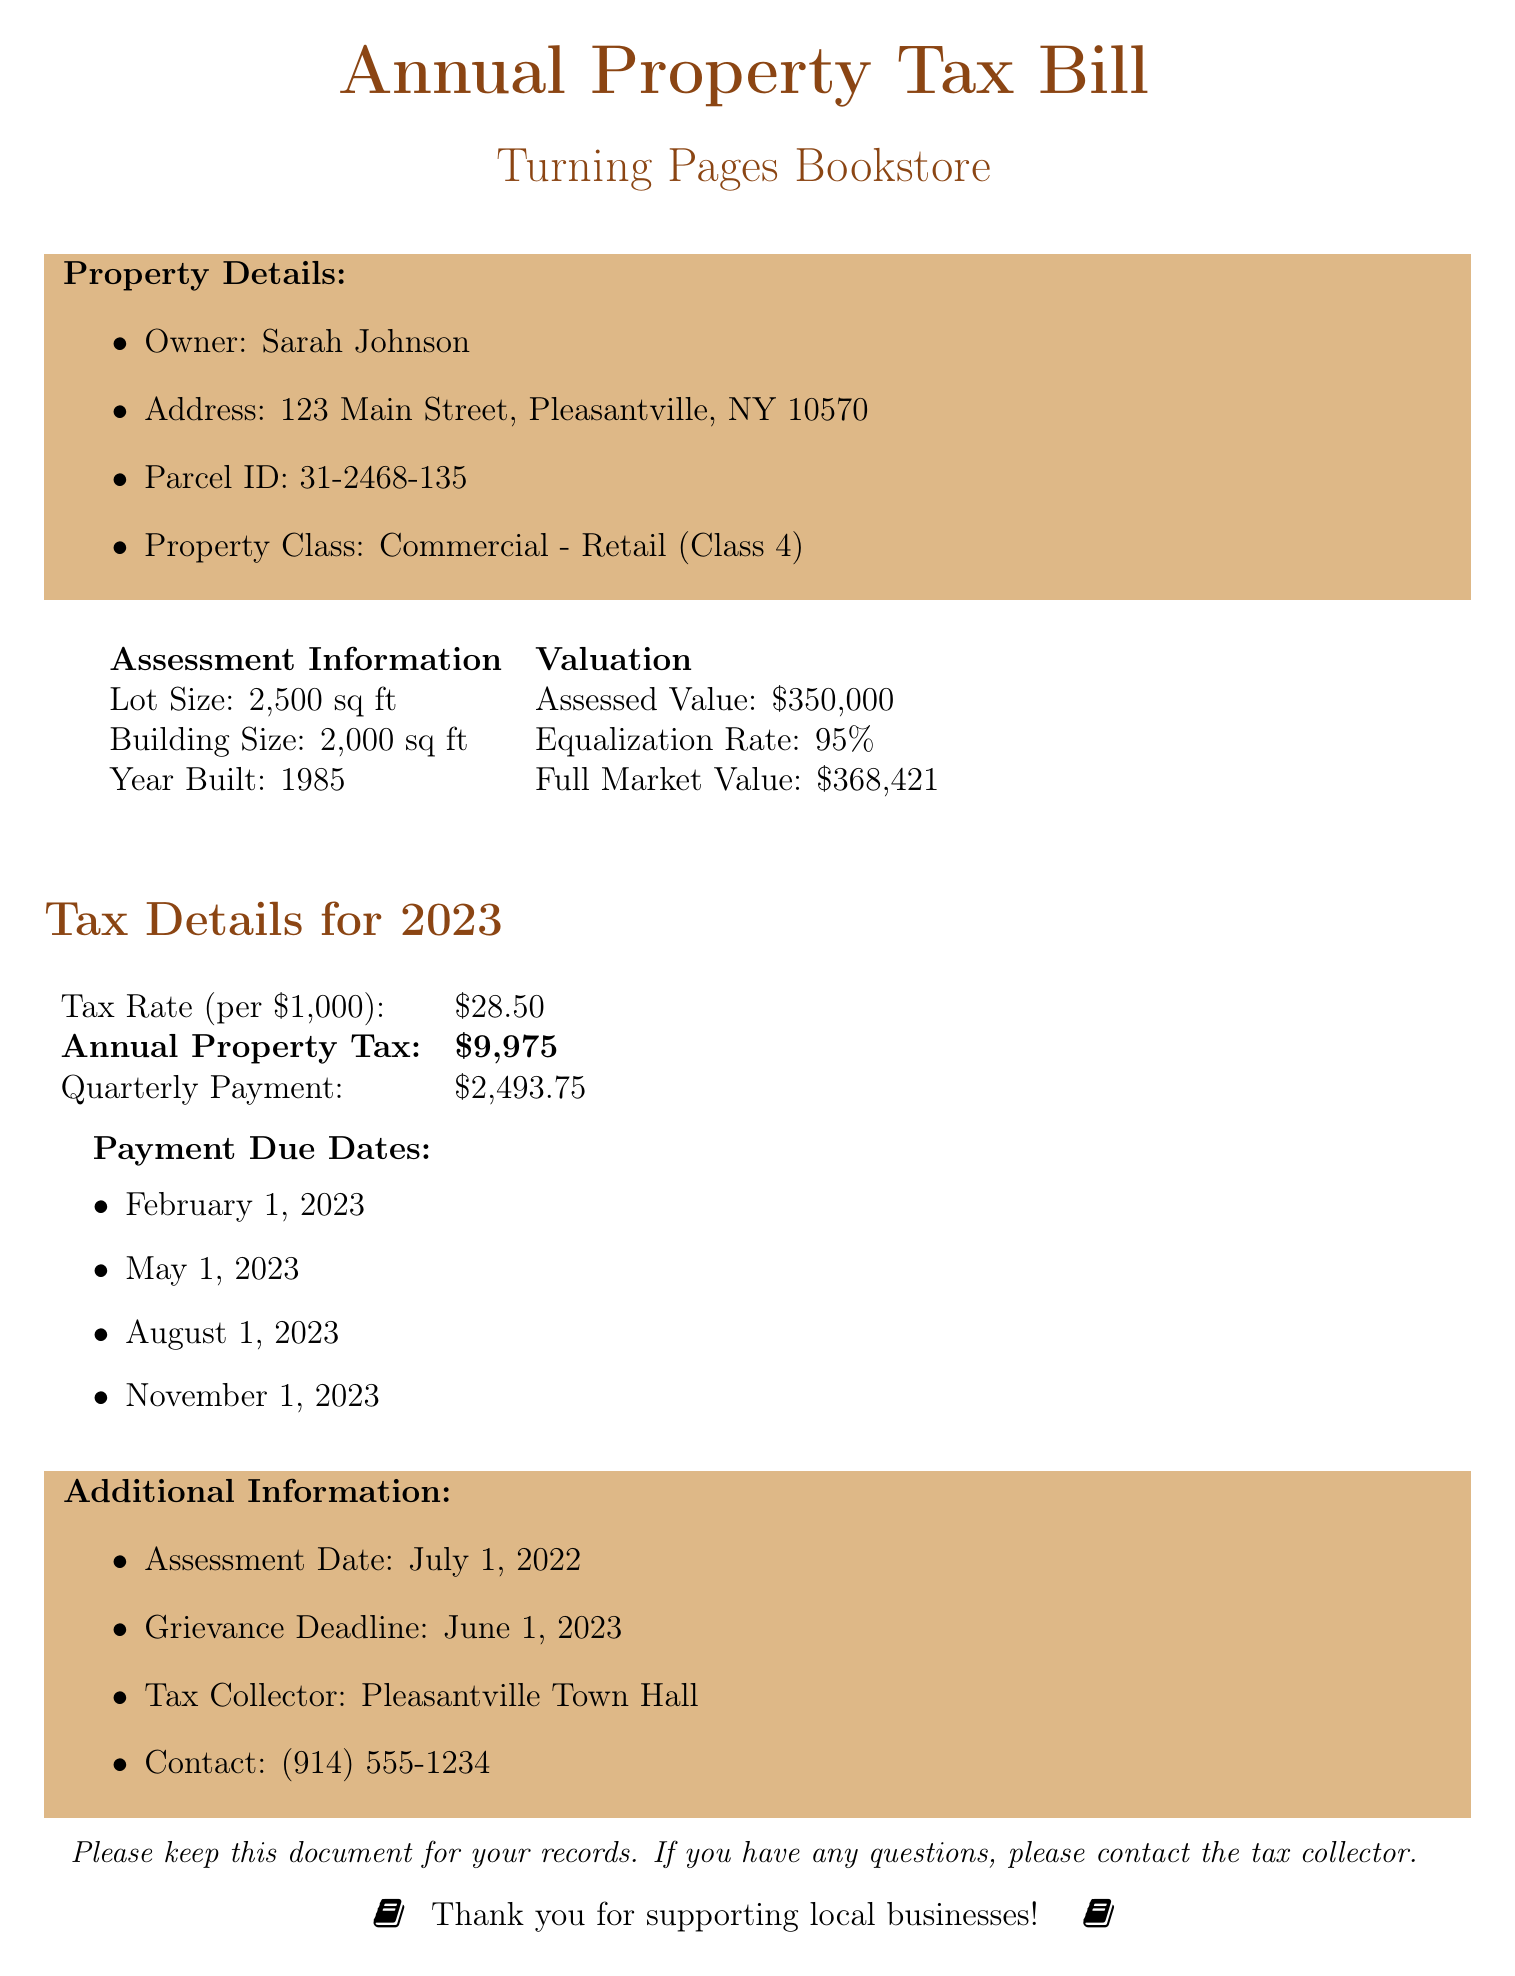What is the assessed value? The assessed value is listed as the valuation for the property, which is \$350,000.
Answer: \$350,000 Who is the property owner? The document states that the owner of the property is Sarah Johnson.
Answer: Sarah Johnson What is the property class? The property class is specified as Commercial - Retail (Class 4).
Answer: Commercial - Retail (Class 4) What is the tax rate per thousand? The tax rate provided in the document is \$28.50 per \$1,000 of assessed value.
Answer: \$28.50 When is the grievance deadline? The grievance deadline is a specific date mentioned in the document: June 1, 2023.
Answer: June 1, 2023 What is the total annual property tax? The total annual property tax is calculated and presented in the document as \$9,975.
Answer: \$9,975 How many quarterly payments are due? The document specifies that there are four quarterly payment due dates for the property tax.
Answer: Four In what year was the building constructed? The year built for the property is indicated in the document as 1985.
Answer: 1985 What is the full market value? The full market value of the property is given in the assessment information as \$368,421.
Answer: \$368,421 